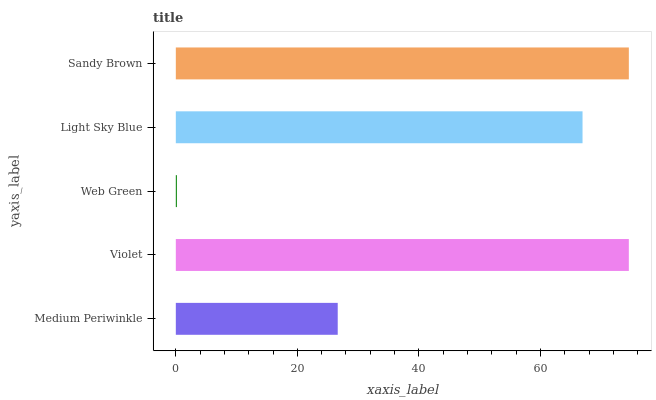Is Web Green the minimum?
Answer yes or no. Yes. Is Sandy Brown the maximum?
Answer yes or no. Yes. Is Violet the minimum?
Answer yes or no. No. Is Violet the maximum?
Answer yes or no. No. Is Violet greater than Medium Periwinkle?
Answer yes or no. Yes. Is Medium Periwinkle less than Violet?
Answer yes or no. Yes. Is Medium Periwinkle greater than Violet?
Answer yes or no. No. Is Violet less than Medium Periwinkle?
Answer yes or no. No. Is Light Sky Blue the high median?
Answer yes or no. Yes. Is Light Sky Blue the low median?
Answer yes or no. Yes. Is Medium Periwinkle the high median?
Answer yes or no. No. Is Sandy Brown the low median?
Answer yes or no. No. 